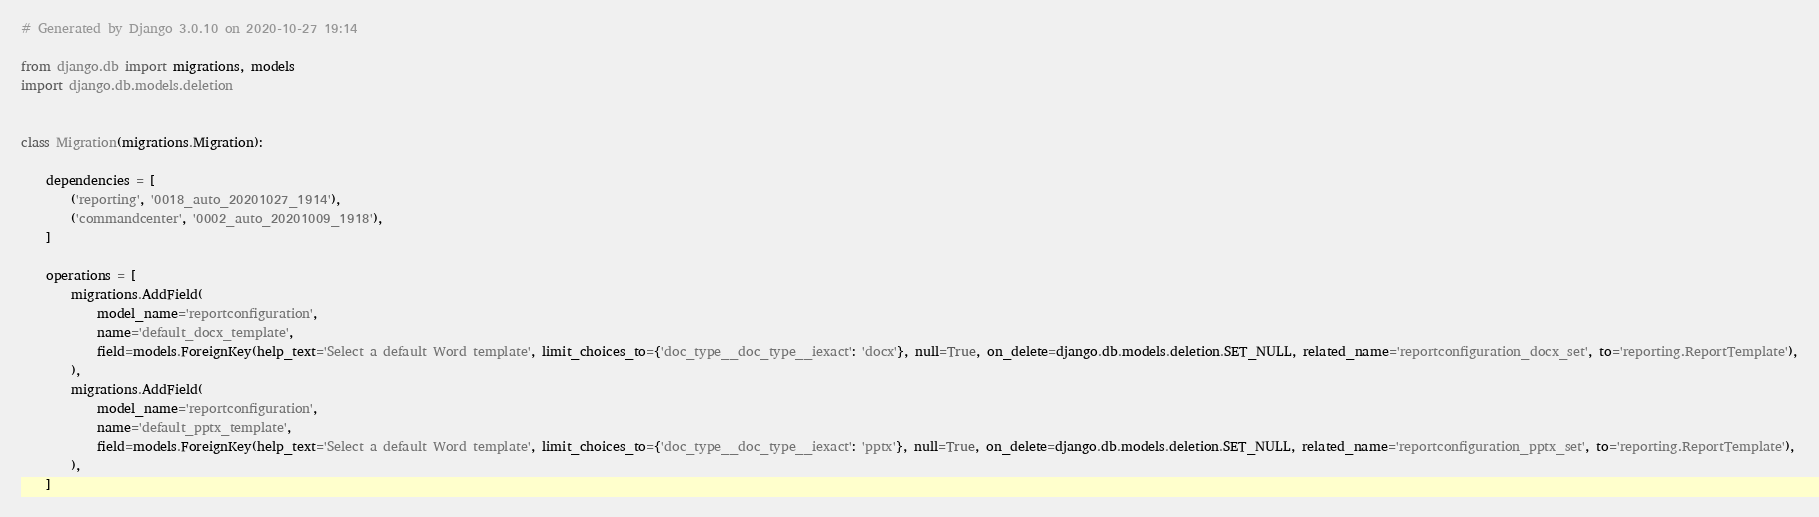Convert code to text. <code><loc_0><loc_0><loc_500><loc_500><_Python_># Generated by Django 3.0.10 on 2020-10-27 19:14

from django.db import migrations, models
import django.db.models.deletion


class Migration(migrations.Migration):

    dependencies = [
        ('reporting', '0018_auto_20201027_1914'),
        ('commandcenter', '0002_auto_20201009_1918'),
    ]

    operations = [
        migrations.AddField(
            model_name='reportconfiguration',
            name='default_docx_template',
            field=models.ForeignKey(help_text='Select a default Word template', limit_choices_to={'doc_type__doc_type__iexact': 'docx'}, null=True, on_delete=django.db.models.deletion.SET_NULL, related_name='reportconfiguration_docx_set', to='reporting.ReportTemplate'),
        ),
        migrations.AddField(
            model_name='reportconfiguration',
            name='default_pptx_template',
            field=models.ForeignKey(help_text='Select a default Word template', limit_choices_to={'doc_type__doc_type__iexact': 'pptx'}, null=True, on_delete=django.db.models.deletion.SET_NULL, related_name='reportconfiguration_pptx_set', to='reporting.ReportTemplate'),
        ),
    ]
</code> 